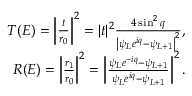Convert formula to latex. <formula><loc_0><loc_0><loc_500><loc_500>\begin{array} { r l r } & { { T } ( E ) = \left | \frac { t } { r _ { 0 } } \right | ^ { 2 } = | t | ^ { 2 } \frac { 4 \sin ^ { 2 } q } { \left | \psi _ { L } e ^ { i q } - \psi _ { L + 1 } \right | ^ { 2 } } , } \\ & { { R } ( E ) = \left | \frac { r _ { 1 } } { r _ { 0 } } \right | ^ { 2 } = \left | \frac { \psi _ { L } e ^ { - i q } - \psi _ { L + 1 } } { \psi _ { L } e ^ { i q } - \psi _ { L + 1 } } \right | ^ { 2 } . } \end{array}</formula> 